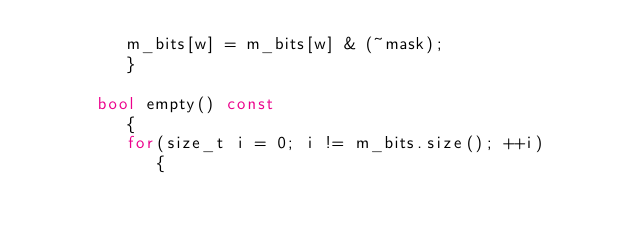Convert code to text. <code><loc_0><loc_0><loc_500><loc_500><_C++_>         m_bits[w] = m_bits[w] & (~mask);
         }

      bool empty() const
         {
         for(size_t i = 0; i != m_bits.size(); ++i)
            {</code> 